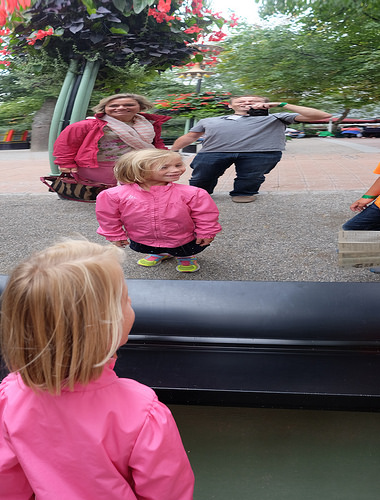<image>
Is there a girl in front of the reflection? Yes. The girl is positioned in front of the reflection, appearing closer to the camera viewpoint. 